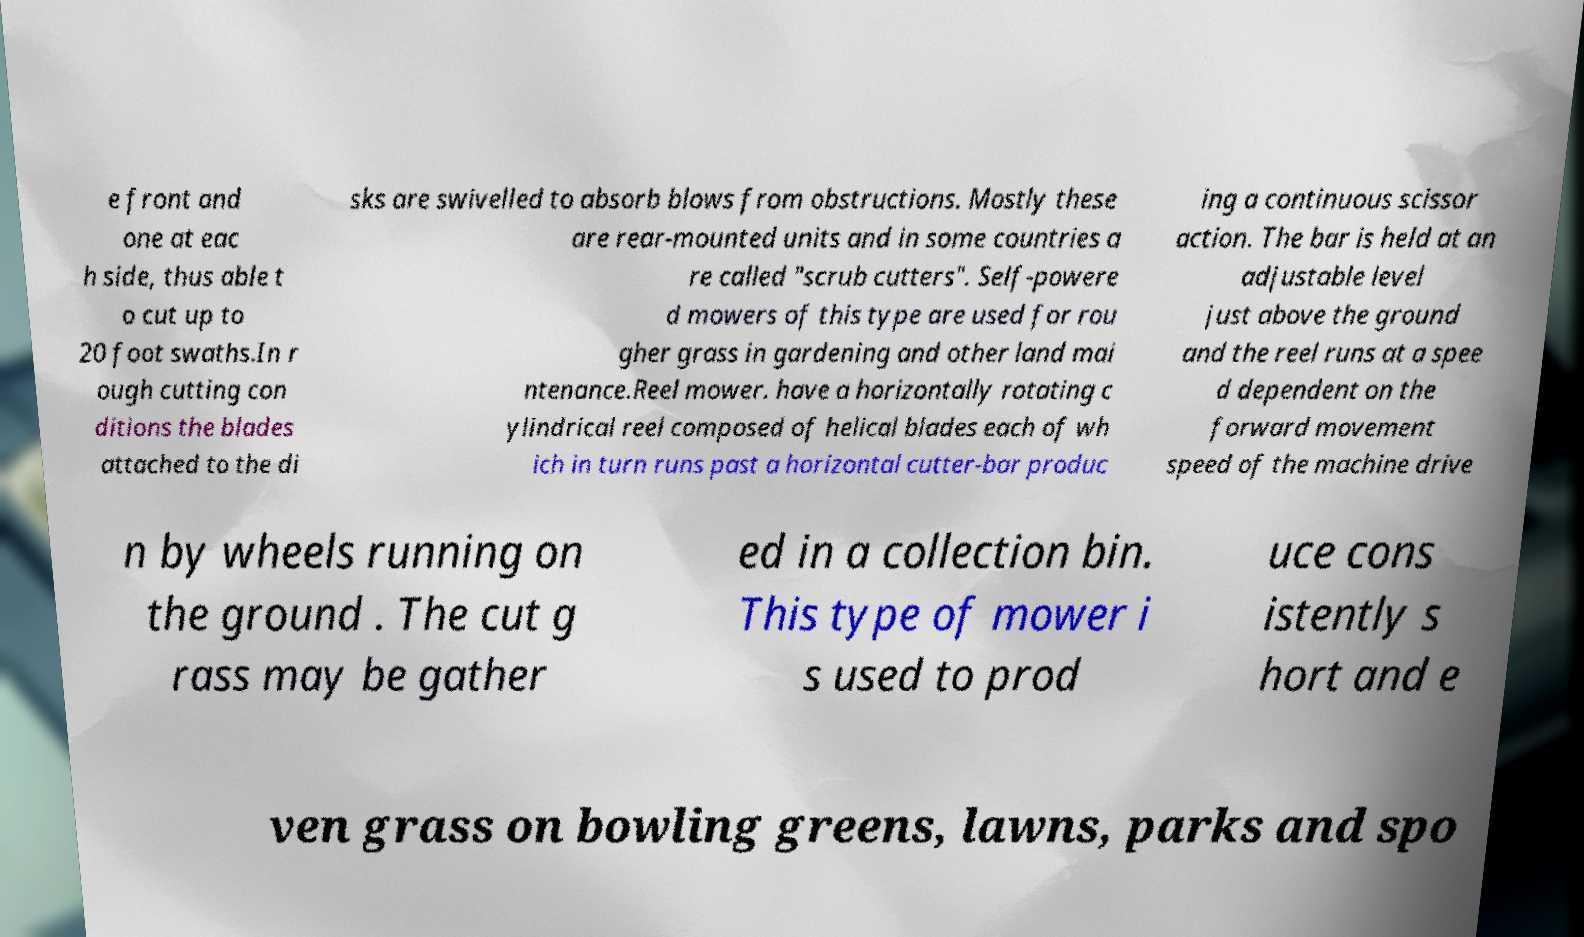Please identify and transcribe the text found in this image. e front and one at eac h side, thus able t o cut up to 20 foot swaths.In r ough cutting con ditions the blades attached to the di sks are swivelled to absorb blows from obstructions. Mostly these are rear-mounted units and in some countries a re called "scrub cutters". Self-powere d mowers of this type are used for rou gher grass in gardening and other land mai ntenance.Reel mower. have a horizontally rotating c ylindrical reel composed of helical blades each of wh ich in turn runs past a horizontal cutter-bar produc ing a continuous scissor action. The bar is held at an adjustable level just above the ground and the reel runs at a spee d dependent on the forward movement speed of the machine drive n by wheels running on the ground . The cut g rass may be gather ed in a collection bin. This type of mower i s used to prod uce cons istently s hort and e ven grass on bowling greens, lawns, parks and spo 